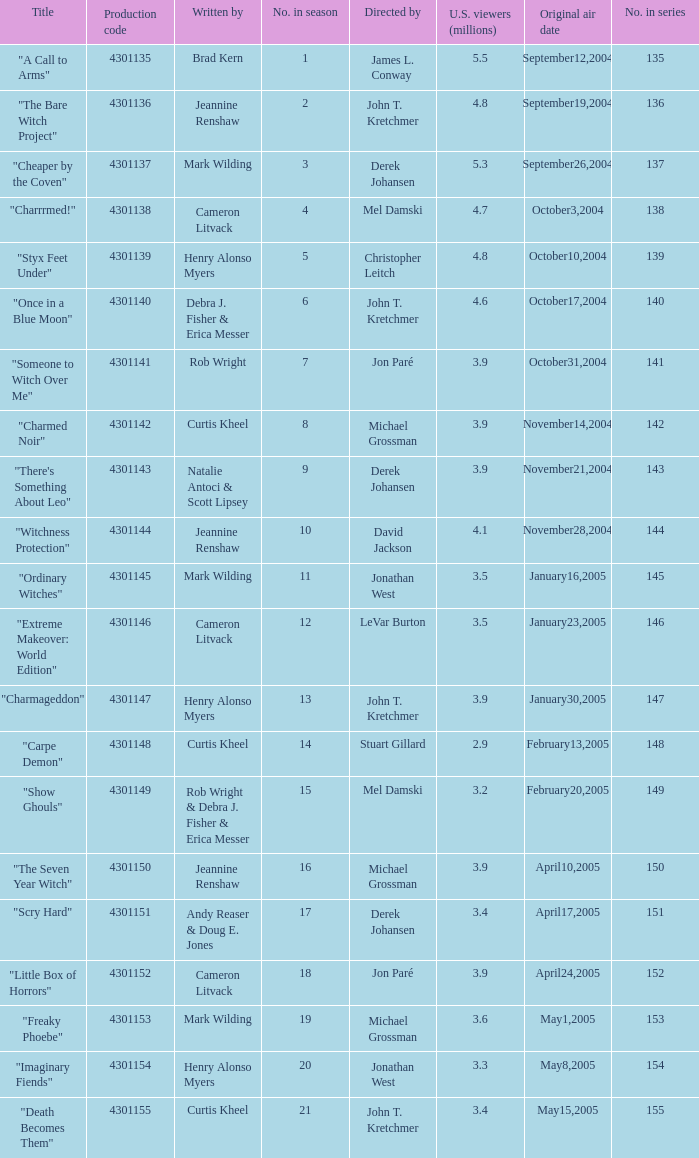Give me the full table as a dictionary. {'header': ['Title', 'Production code', 'Written by', 'No. in season', 'Directed by', 'U.S. viewers (millions)', 'Original air date', 'No. in series'], 'rows': [['"A Call to Arms"', '4301135', 'Brad Kern', '1', 'James L. Conway', '5.5', 'September12,2004', '135'], ['"The Bare Witch Project"', '4301136', 'Jeannine Renshaw', '2', 'John T. Kretchmer', '4.8', 'September19,2004', '136'], ['"Cheaper by the Coven"', '4301137', 'Mark Wilding', '3', 'Derek Johansen', '5.3', 'September26,2004', '137'], ['"Charrrmed!"', '4301138', 'Cameron Litvack', '4', 'Mel Damski', '4.7', 'October3,2004', '138'], ['"Styx Feet Under"', '4301139', 'Henry Alonso Myers', '5', 'Christopher Leitch', '4.8', 'October10,2004', '139'], ['"Once in a Blue Moon"', '4301140', 'Debra J. Fisher & Erica Messer', '6', 'John T. Kretchmer', '4.6', 'October17,2004', '140'], ['"Someone to Witch Over Me"', '4301141', 'Rob Wright', '7', 'Jon Paré', '3.9', 'October31,2004', '141'], ['"Charmed Noir"', '4301142', 'Curtis Kheel', '8', 'Michael Grossman', '3.9', 'November14,2004', '142'], ['"There\'s Something About Leo"', '4301143', 'Natalie Antoci & Scott Lipsey', '9', 'Derek Johansen', '3.9', 'November21,2004', '143'], ['"Witchness Protection"', '4301144', 'Jeannine Renshaw', '10', 'David Jackson', '4.1', 'November28,2004', '144'], ['"Ordinary Witches"', '4301145', 'Mark Wilding', '11', 'Jonathan West', '3.5', 'January16,2005', '145'], ['"Extreme Makeover: World Edition"', '4301146', 'Cameron Litvack', '12', 'LeVar Burton', '3.5', 'January23,2005', '146'], ['"Charmageddon"', '4301147', 'Henry Alonso Myers', '13', 'John T. Kretchmer', '3.9', 'January30,2005', '147'], ['"Carpe Demon"', '4301148', 'Curtis Kheel', '14', 'Stuart Gillard', '2.9', 'February13,2005', '148'], ['"Show Ghouls"', '4301149', 'Rob Wright & Debra J. Fisher & Erica Messer', '15', 'Mel Damski', '3.2', 'February20,2005', '149'], ['"The Seven Year Witch"', '4301150', 'Jeannine Renshaw', '16', 'Michael Grossman', '3.9', 'April10,2005', '150'], ['"Scry Hard"', '4301151', 'Andy Reaser & Doug E. Jones', '17', 'Derek Johansen', '3.4', 'April17,2005', '151'], ['"Little Box of Horrors"', '4301152', 'Cameron Litvack', '18', 'Jon Paré', '3.9', 'April24,2005', '152'], ['"Freaky Phoebe"', '4301153', 'Mark Wilding', '19', 'Michael Grossman', '3.6', 'May1,2005', '153'], ['"Imaginary Fiends"', '4301154', 'Henry Alonso Myers', '20', 'Jonathan West', '3.3', 'May8,2005', '154'], ['"Death Becomes Them"', '4301155', 'Curtis Kheel', '21', 'John T. Kretchmer', '3.4', 'May15,2005', '155']]} What is the no in series when rob wright & debra j. fisher & erica messer were the writers? 149.0. 